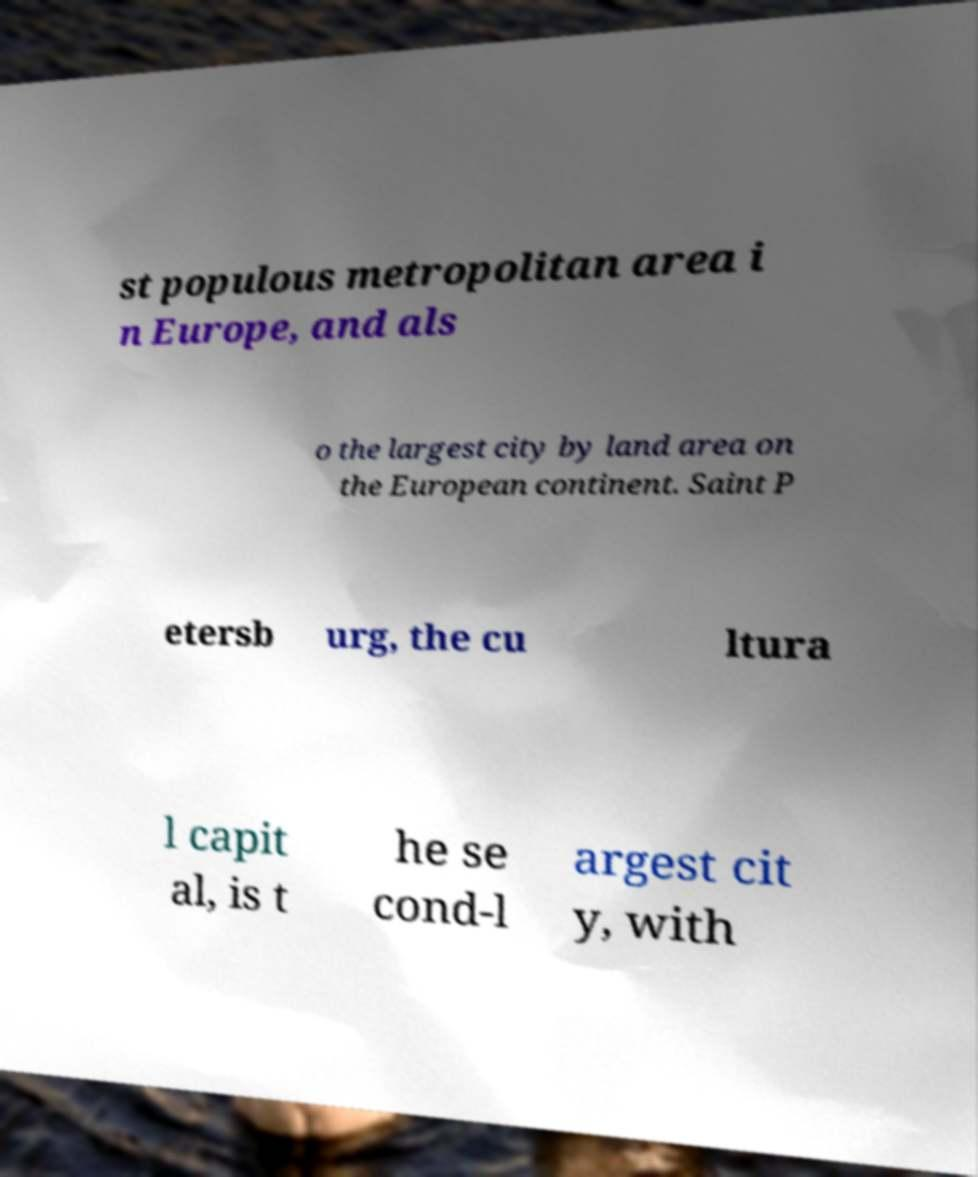Could you extract and type out the text from this image? st populous metropolitan area i n Europe, and als o the largest city by land area on the European continent. Saint P etersb urg, the cu ltura l capit al, is t he se cond-l argest cit y, with 